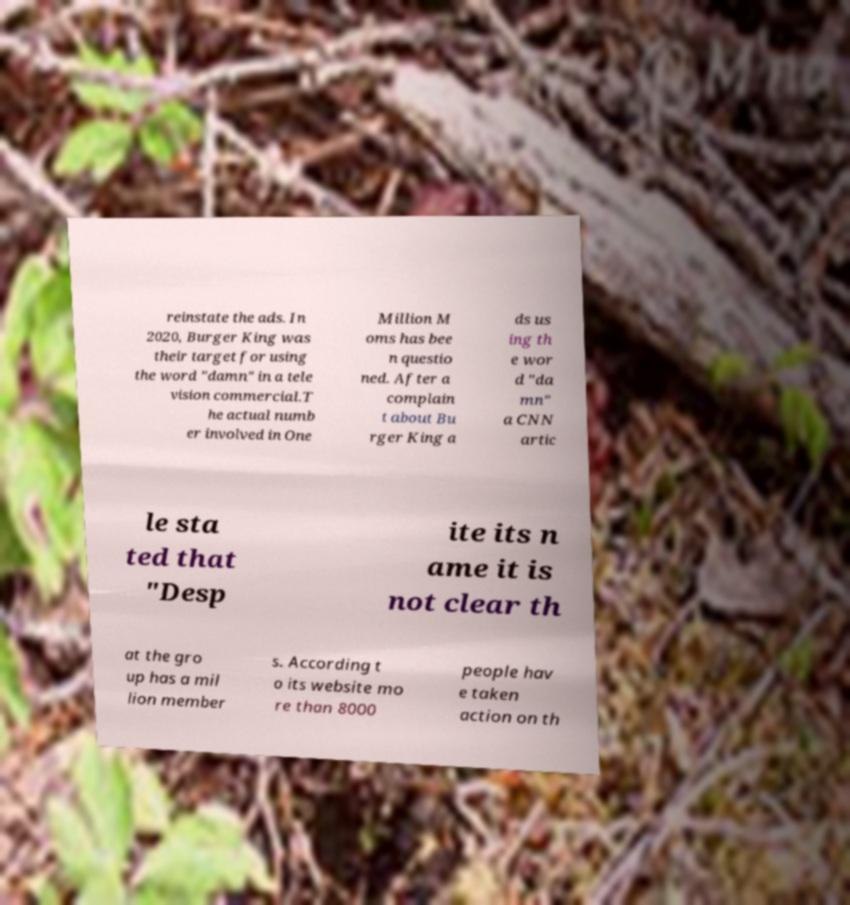What messages or text are displayed in this image? I need them in a readable, typed format. reinstate the ads. In 2020, Burger King was their target for using the word "damn" in a tele vision commercial.T he actual numb er involved in One Million M oms has bee n questio ned. After a complain t about Bu rger King a ds us ing th e wor d "da mn" a CNN artic le sta ted that "Desp ite its n ame it is not clear th at the gro up has a mil lion member s. According t o its website mo re than 8000 people hav e taken action on th 